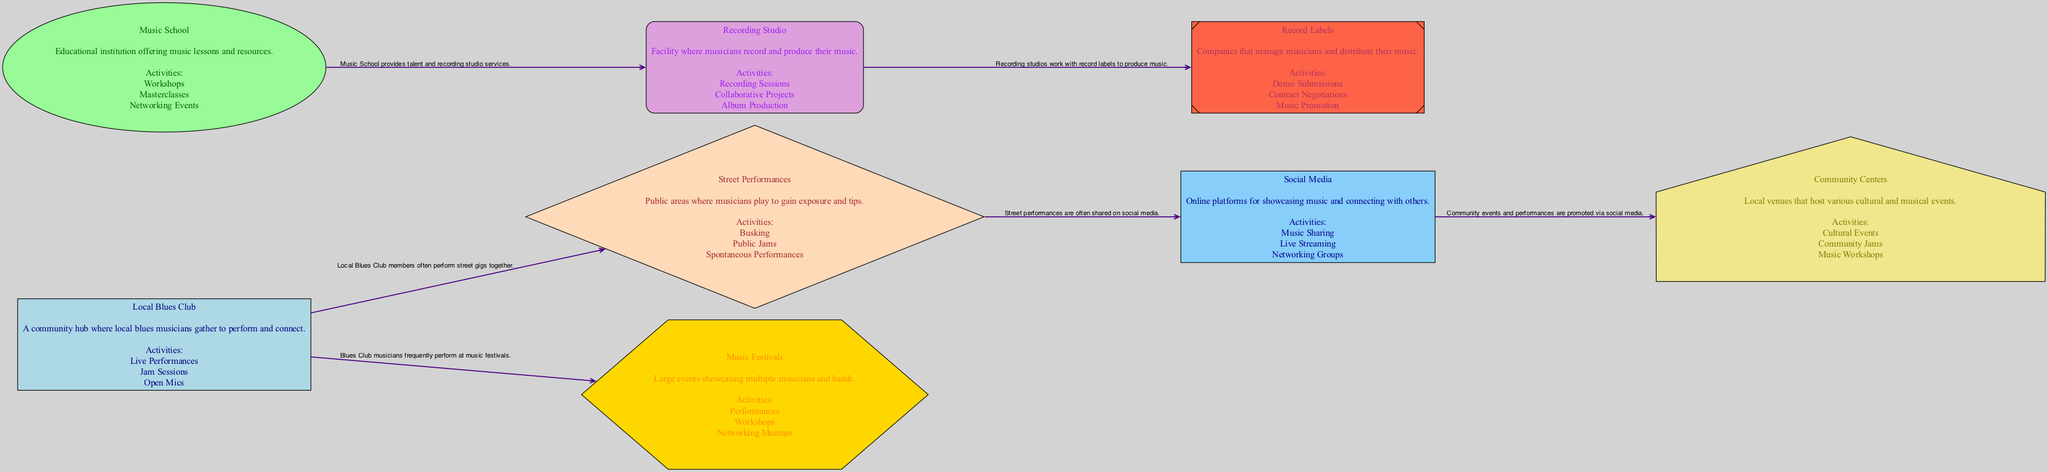What is the main hub for local blues musicians? The diagram identifies "Local Blues Club" as the central node connecting to various other nodes, indicating it serves as a gathering place for blues musicians to perform and connect.
Answer: Local Blues Club How many nodes are present in the diagram? By counting each distinct entity in the diagram, we find there are 8 nodes labeled as Local Blues Club, Music School, Street Performances, Recording Studio, Music Festivals, Social Media, Community Centers, and Record Labels.
Answer: 8 What activity is associated with the Music School? Looking at the node labeled "Music School," its activities include Workshops, Masterclasses, and Networking Events, all of which support musicians' growth and connection.
Answer: Workshops Which two nodes are connected by recording studio services? The "Recording Studio" node connects to "Record Labels" as they work together to produce music, showcasing the collaborative nature of the music industry represented in the diagram.
Answer: Recording Studio and Record Labels What social platform is mentioned for showcasing music? The node describing "Social Media" highlights its role as an online platform for "Music Sharing," "Live Streaming," and "Networking Groups," indicating its importance for musicians.
Answer: Social Media How do Local Blues Club musicians commonly perform? The relationship described in the diagram shows that members of the "Local Blues Club" frequently perform together in "Street Performances," indicating their collaboration in public settings.
Answer: Street Performances Which entities are involved in the music festival activities? The "Music Festivals" node connects to "Local Blues Club," indicating that musicians from the local club perform at festivals, making it clear they are involved in these activities.
Answer: Local Blues Club and Music Festivals How is the connection between Street Performances and Social Media described? The diagram illustrates that street performances are often shared on social media, reflecting the modern method of gaining exposure for musicians through digital platforms.
Answer: Shared on social media What type of events do Community Centers host? The "Community Centers" node specifies activities such as "Cultural Events," "Community Jams," and "Music Workshops," indicating a diverse range of musical and cultural gatherings.
Answer: Cultural Events 